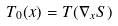Convert formula to latex. <formula><loc_0><loc_0><loc_500><loc_500>T _ { 0 } ( x ) = T ( \nabla _ { x } S )</formula> 